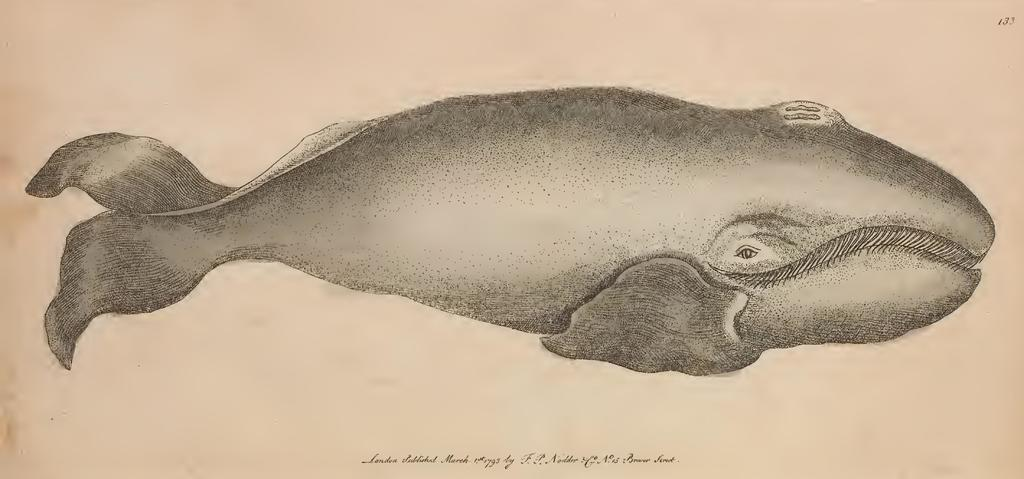What is the main subject in the foreground of the image? There is a sketch of a fish in the foreground of the image. How many crows are attending the party in the image? There is no party or crows present in the image; it features a sketch of a fish in the foreground. 